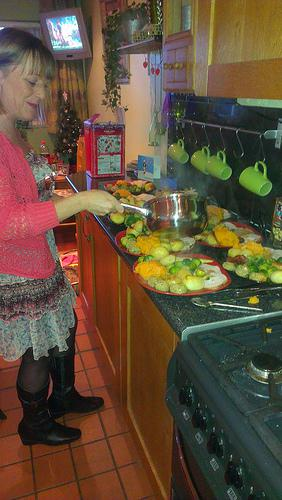Question: what are hanging from hooks?
Choices:
A. Cups.
B. Tools.
C. Spoons.
D. Hats.
Answer with the letter. Answer: A Question: how many cups are there?
Choices:
A. Three.
B. Two.
C. Four.
D. One.
Answer with the letter. Answer: C Question: what is in the background?
Choices:
A. A dog.
B. A barn.
C. A school.
D. A TV.
Answer with the letter. Answer: D Question: why is the woman pouring?
Choices:
A. To prepare meals.
B. To pour drinks.
C. To measure liquids.
D. To dump out water.
Answer with the letter. Answer: A 